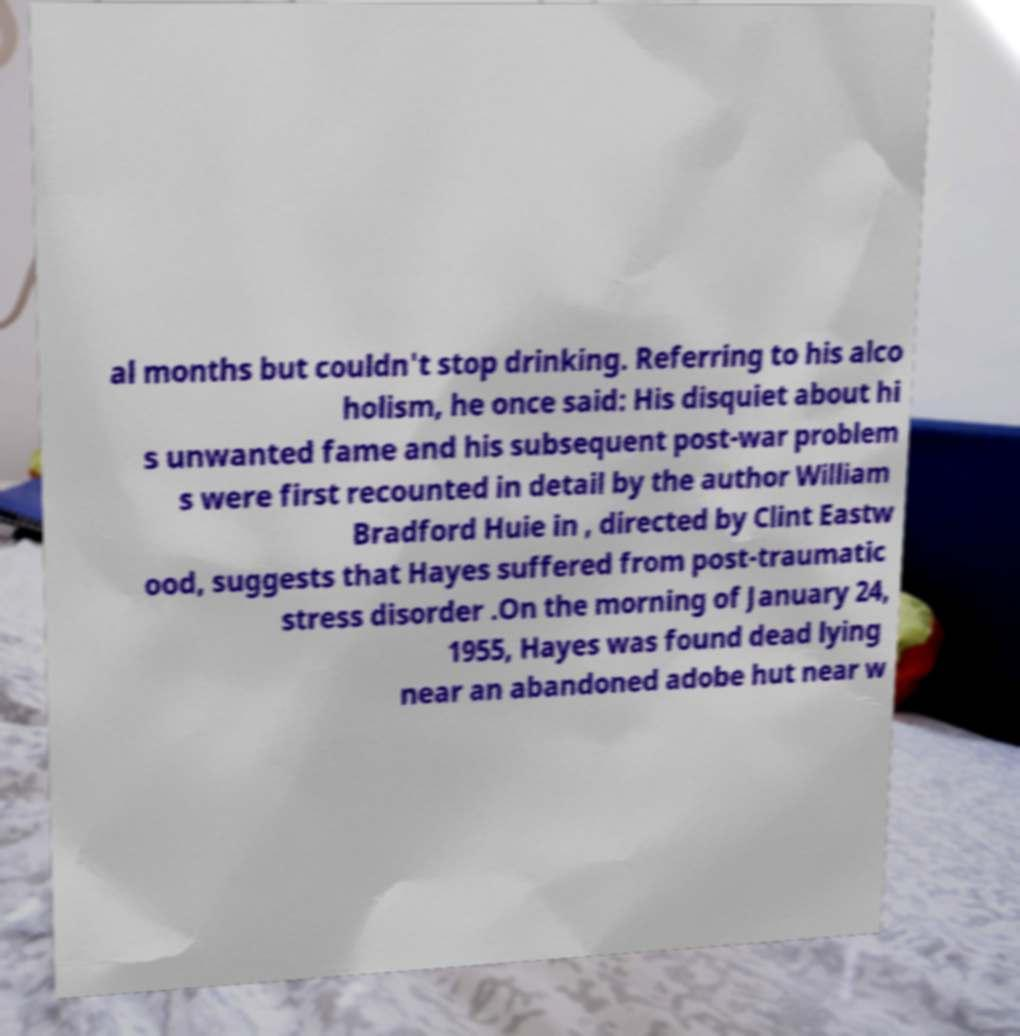Could you assist in decoding the text presented in this image and type it out clearly? al months but couldn't stop drinking. Referring to his alco holism, he once said: His disquiet about hi s unwanted fame and his subsequent post-war problem s were first recounted in detail by the author William Bradford Huie in , directed by Clint Eastw ood, suggests that Hayes suffered from post-traumatic stress disorder .On the morning of January 24, 1955, Hayes was found dead lying near an abandoned adobe hut near w 